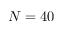Convert formula to latex. <formula><loc_0><loc_0><loc_500><loc_500>N = 4 0</formula> 